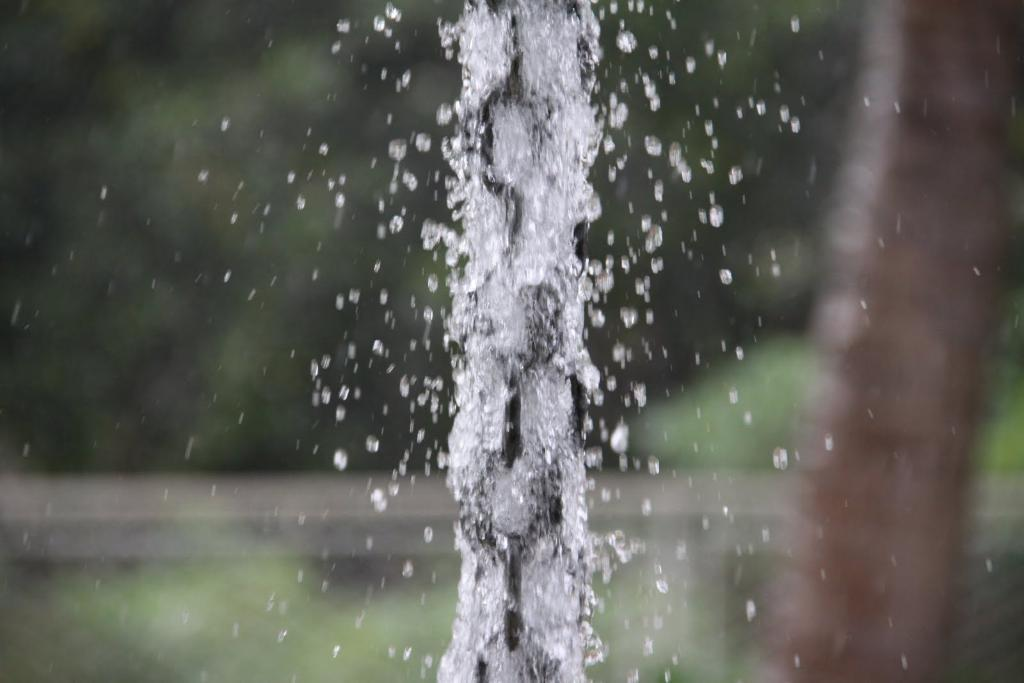What is visible in the image? Water is visible in the image. Can you describe the background of the image? The background of the image is blurred. How many pies are floating in the water in the image? There are no pies present in the image; it only features water. 